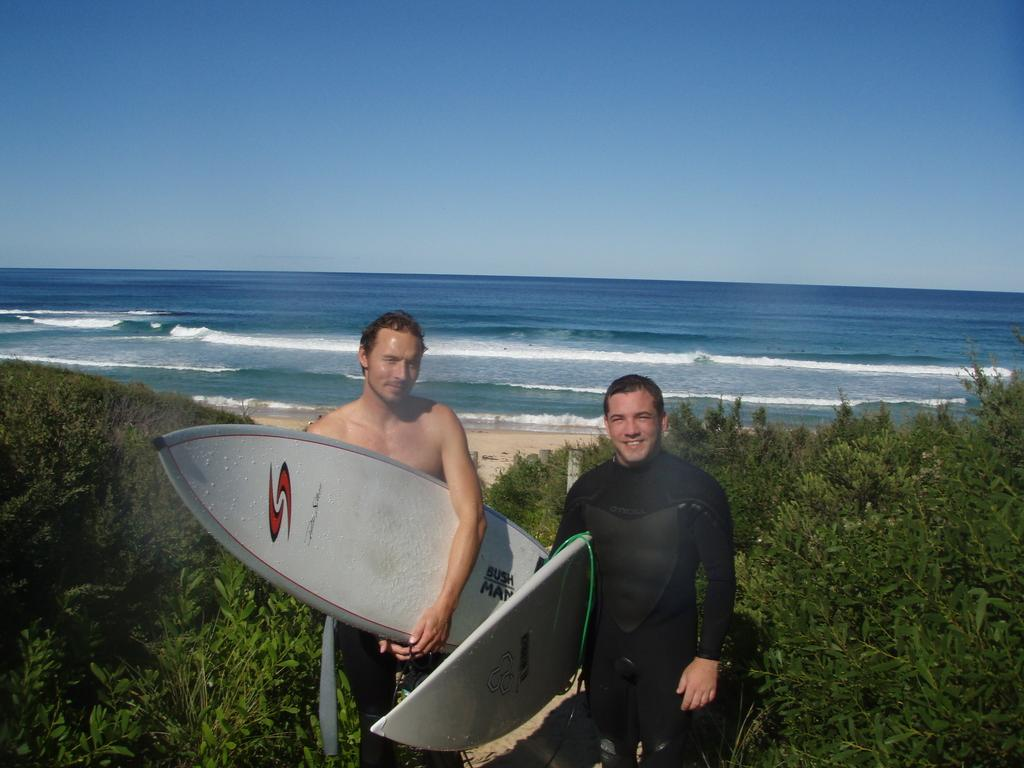What type of environment is depicted in the image? There is a lot of greenery, a beach, and a sea in the image, suggesting a natural, coastal environment. What activities might the two men be engaged in? The two men are holding surfing boards, which suggests they might be preparing to surf. Can you describe the water in the image? The water in the image is the sea, which is a large body of saltwater. What type of fuel is being used by the hour in the image? There is no hour or fuel present in the image; it features a natural, coastal environment with two men holding surfing boards. 